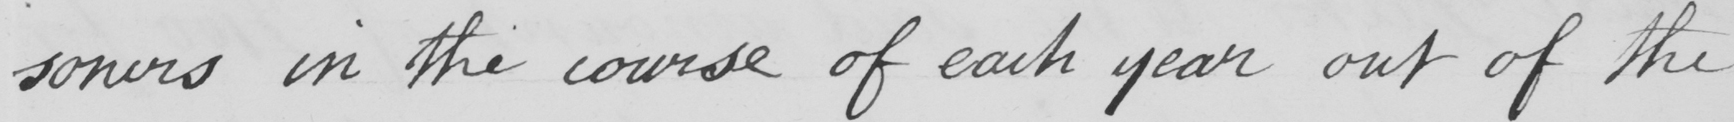Can you tell me what this handwritten text says? -soners in the course of each year out of the 